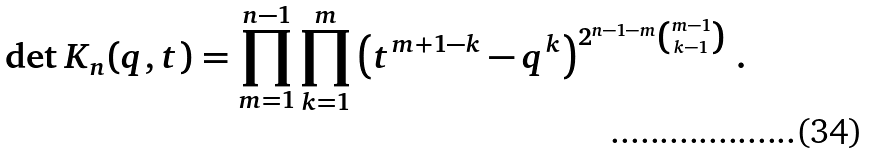<formula> <loc_0><loc_0><loc_500><loc_500>\det K _ { n } ( q , t ) = \prod _ { m = 1 } ^ { n - 1 } \prod _ { k = 1 } ^ { m } \left ( t ^ { m + 1 - k } - q ^ { k } \right ) ^ { 2 ^ { n - 1 - m } { m - 1 \choose k - 1 } } \, .</formula> 